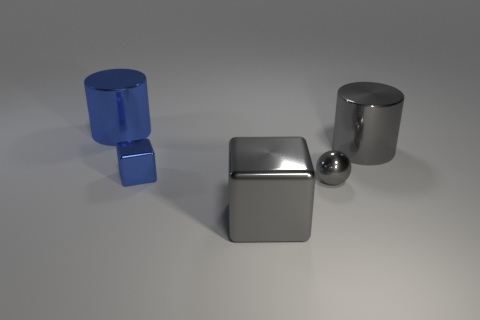Do the small metallic ball and the tiny thing that is to the left of the big block have the same color?
Ensure brevity in your answer.  No. Is there anything else that has the same shape as the small blue thing?
Offer a terse response. Yes. There is a large metallic thing right of the large gray thing on the left side of the large gray cylinder; what is its color?
Your answer should be very brief. Gray. What number of tiny metal blocks are there?
Keep it short and to the point. 1. What number of rubber things are either large gray blocks or small objects?
Your response must be concise. 0. How many metallic objects are the same color as the large block?
Provide a succinct answer. 2. What is the material of the small blue thing that is to the left of the big shiny thing in front of the gray metal sphere?
Provide a short and direct response. Metal. What is the size of the gray shiny cylinder?
Offer a terse response. Large. What number of things have the same size as the gray metallic sphere?
Offer a very short reply. 1. What number of large things have the same shape as the tiny blue metallic object?
Your answer should be very brief. 1. 